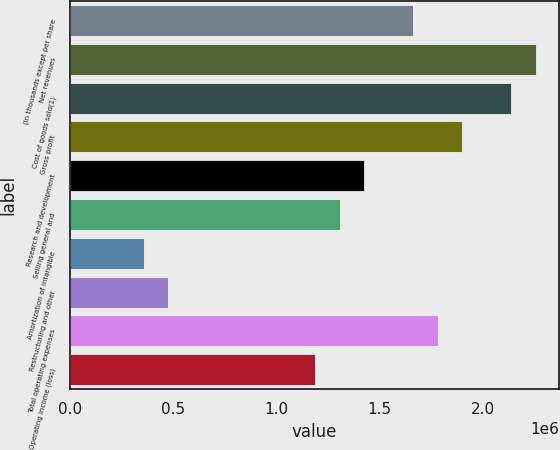Convert chart. <chart><loc_0><loc_0><loc_500><loc_500><bar_chart><fcel>(In thousands except per share<fcel>Net revenues<fcel>Cost of goods sold(1)<fcel>Gross profit<fcel>Research and development<fcel>Selling general and<fcel>Amortization of intangible<fcel>Restructuring and other<fcel>Total operating expenses<fcel>Operating income (loss)<nl><fcel>1.66437e+06<fcel>2.25878e+06<fcel>2.1399e+06<fcel>1.90213e+06<fcel>1.4266e+06<fcel>1.30772e+06<fcel>356650<fcel>475534<fcel>1.78325e+06<fcel>1.18883e+06<nl></chart> 